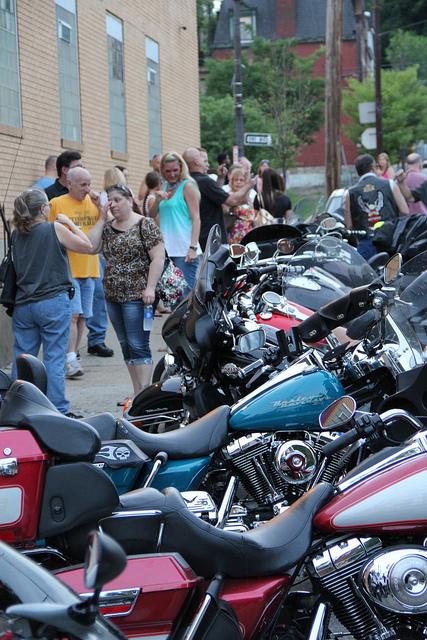What texture is the woman's hair?
Answer briefly. Straight. Are these World War II era bikes?
Quick response, please. No. How many bikers are wearing leather clothing?
Be succinct. 1. Should she have head protection?
Give a very brief answer. No. What kind of rally might be going on?
Write a very short answer. Motorcycle. 